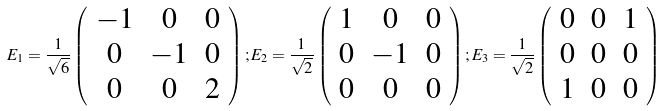<formula> <loc_0><loc_0><loc_500><loc_500>E _ { 1 } = \frac { 1 } { \sqrt { 6 } } \left ( \begin{array} { c c c } - 1 & 0 & 0 \\ 0 & - 1 & 0 \\ 0 & 0 & 2 \end{array} \right ) ; E _ { 2 } = \frac { 1 } { \sqrt { 2 } } \left ( \begin{array} { c c c } 1 & 0 & 0 \\ 0 & - 1 & 0 \\ 0 & 0 & 0 \end{array} \right ) ; E _ { 3 } = \frac { 1 } { \sqrt { 2 } } \left ( \begin{array} { c c c } 0 & 0 & 1 \\ 0 & 0 & 0 \\ 1 & 0 & 0 \end{array} \right )</formula> 